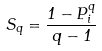Convert formula to latex. <formula><loc_0><loc_0><loc_500><loc_500>S _ { q } = \frac { 1 - P _ { i } ^ { q } } { q - 1 }</formula> 